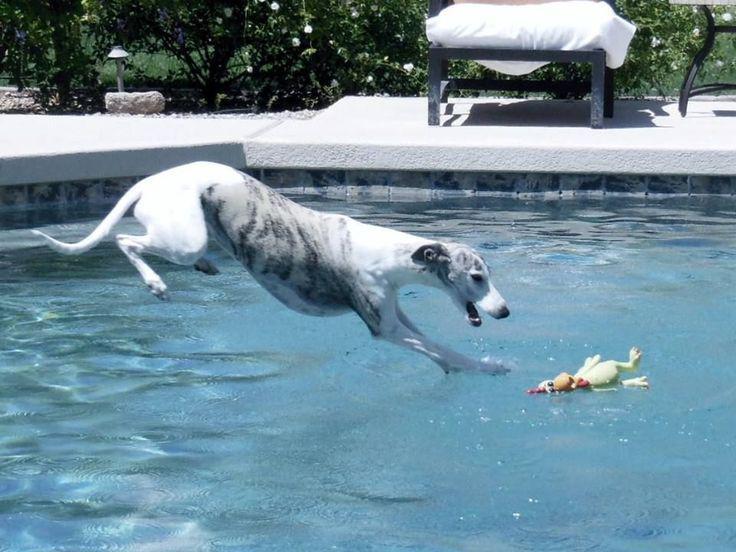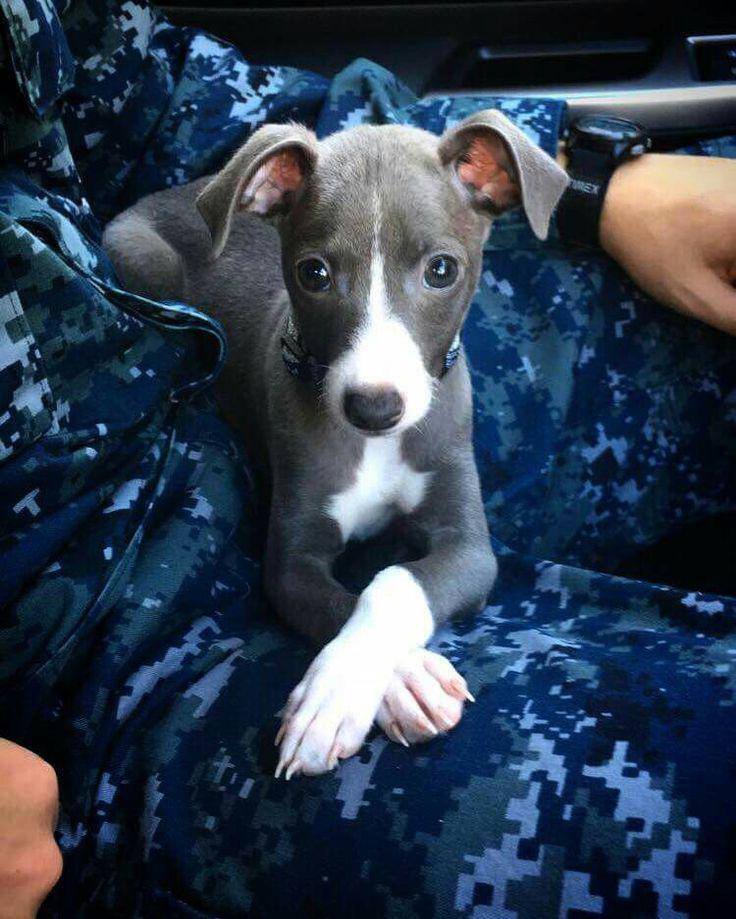The first image is the image on the left, the second image is the image on the right. Considering the images on both sides, is "there is a dog laying in a baby pool in the right image" valid? Answer yes or no. No. The first image is the image on the left, the second image is the image on the right. Examine the images to the left and right. Is the description "At least one dog with dark fur is lying down in a small pool." accurate? Answer yes or no. No. 